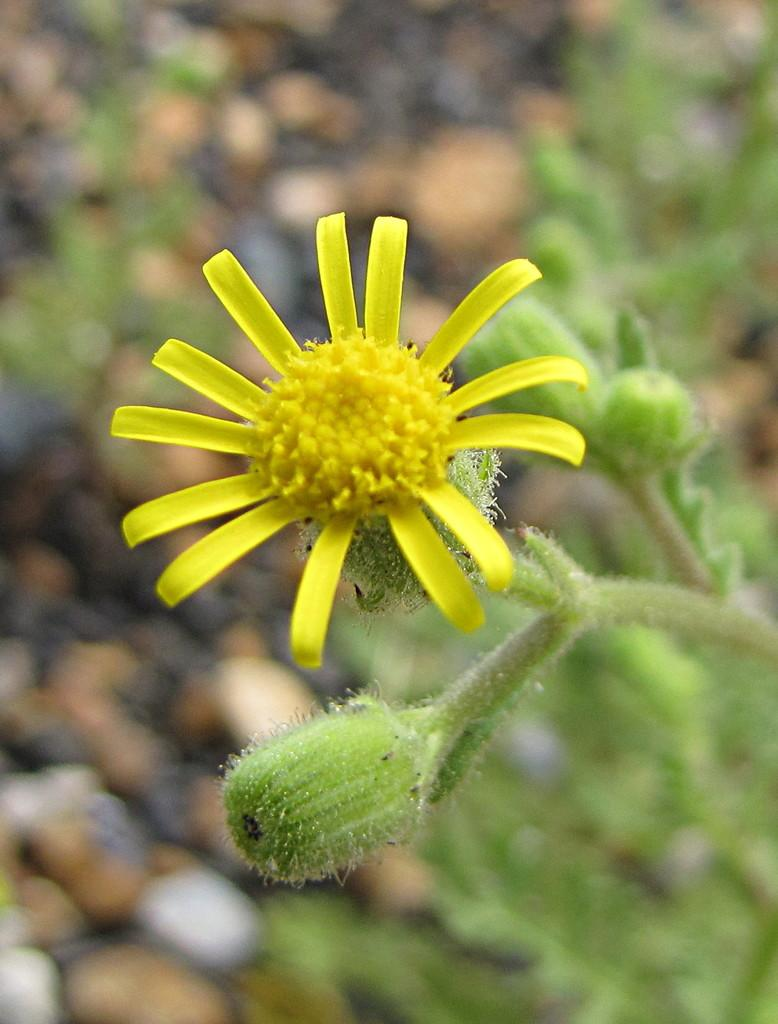What is the main subject of the image? There is a yellow color flower in the center of the image. Can you describe the flower in more detail? The flower has buds. What else can be seen in the image besides the flower? There are other objects visible in the background of the image. How many toes can be seen on the flower in the image? There are no toes visible on the flower in the image, as flowers do not have toes. 